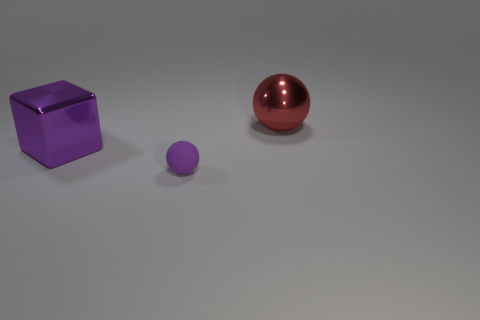What number of gray things are either metallic blocks or rubber balls? In the image, there are no gray objects that can be identified as metallic blocks or rubber balls. We can see a purple (or violet) cube, a smaller purple (or violet) sphere, and a larger red sphere. No gray metallic blocks or gray rubber balls are present. 